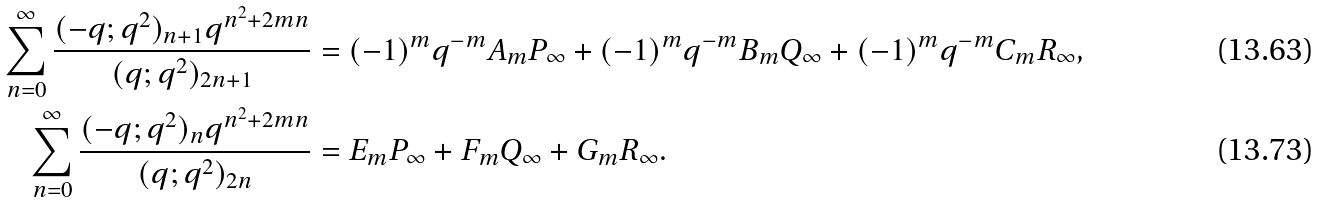Convert formula to latex. <formula><loc_0><loc_0><loc_500><loc_500>\sum _ { n = 0 } ^ { \infty } \frac { ( - q ; q ^ { 2 } ) _ { n + 1 } q ^ { n ^ { 2 } + 2 m n } } { ( q ; q ^ { 2 } ) _ { 2 n + 1 } } & = ( - 1 ) ^ { m } q ^ { - m } A _ { m } P _ { \infty } + ( - 1 ) ^ { m } q ^ { - m } B _ { m } Q _ { \infty } + ( - 1 ) ^ { m } q ^ { - m } C _ { m } R _ { \infty } , \\ \sum _ { n = 0 } ^ { \infty } \frac { ( - q ; q ^ { 2 } ) _ { n } q ^ { n ^ { 2 } + 2 m n } } { ( q ; q ^ { 2 } ) _ { 2 n } } & = E _ { m } P _ { \infty } + F _ { m } Q _ { \infty } + G _ { m } R _ { \infty } .</formula> 